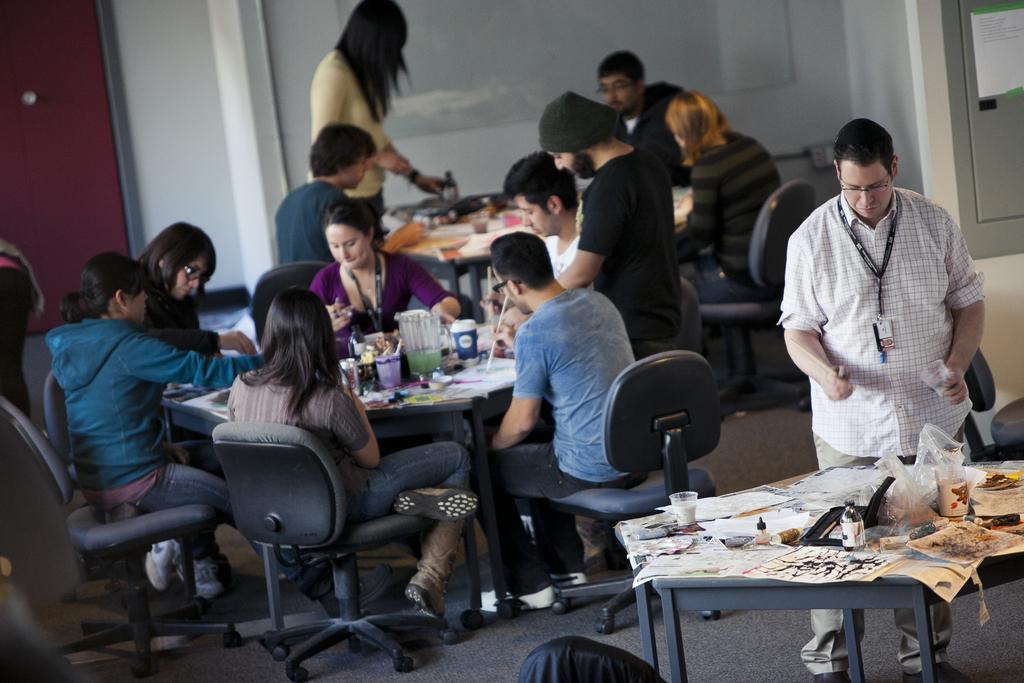How many people are in the image? There is a group of people in the image. What are the people doing in the image? The people are sitting on chairs, and two persons are standing. What objects can be seen on the table in the image? There is a bottle, a pen, paper, and a glass on the table. What type of jewel can be seen on the table in the image? There is no jewel present on the table in the image. Is there a spring season depicted in the image? The image does not depict a specific season or weather condition; it only shows a group of people and objects on a table. 